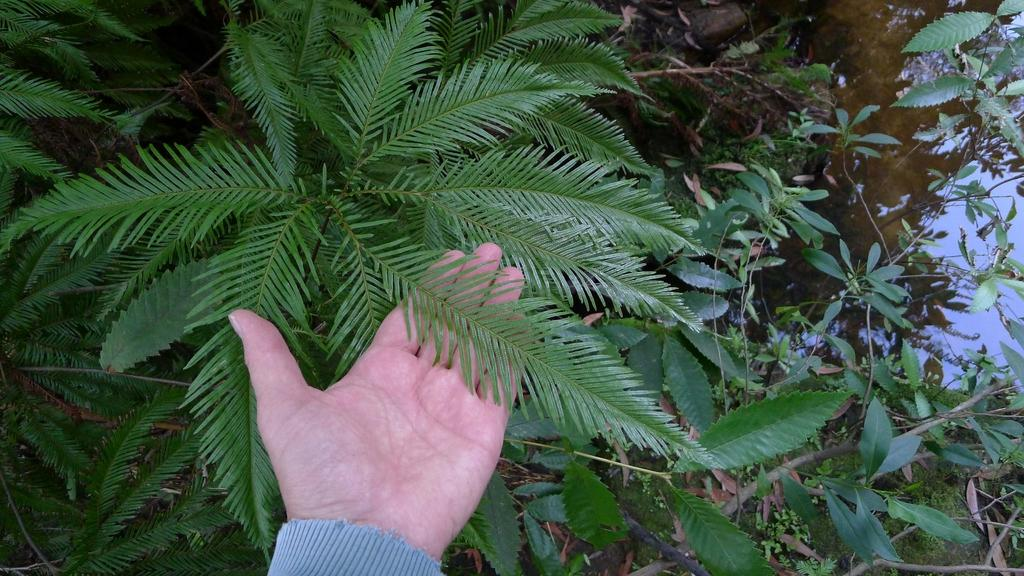What is the human hand in the image doing? The human hand is touching the leaves of a plant. Can you describe the plant in the image? The plant is not described in the provided facts, but the human hand is touching its leaves. What is visible on the right side of the image? There is water on the right side of the image. What type of stocking is being used to cut the prison bars in the image? There is no stocking or prison bars present in the image; it features a human hand touching a plant's leaves and water on the right side. Is there a knife visible in the image? No, there is no knife present in the image. 